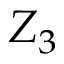<formula> <loc_0><loc_0><loc_500><loc_500>Z _ { 3 }</formula> 